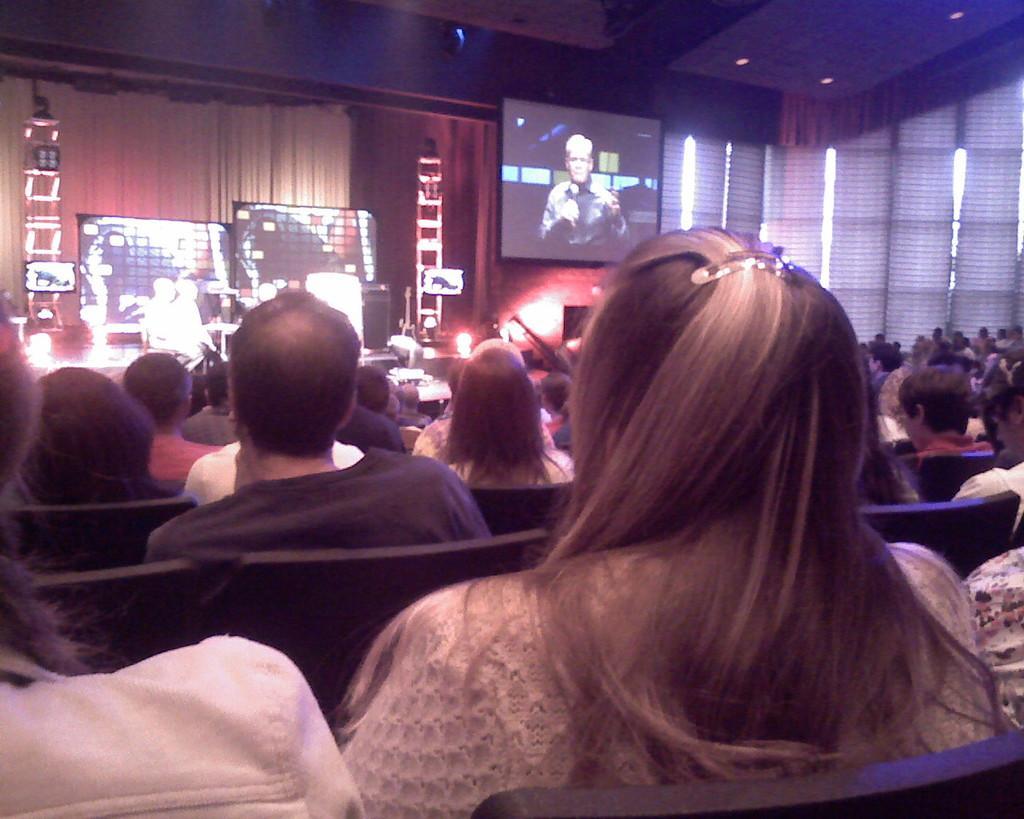Could you give a brief overview of what you see in this image? In the image we can see there are people sitting and they are wearing clothes. We can even see there are many chairs and the lights. Here we can see the screens. 